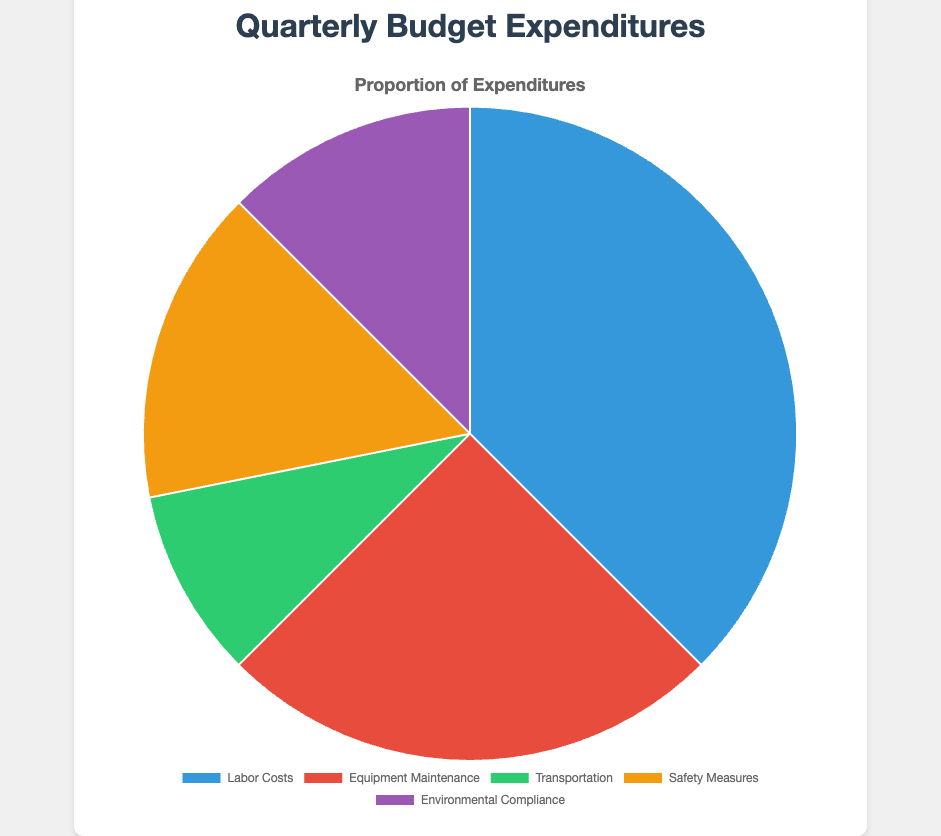What category has the highest expenditure? By looking at the pie chart, the slice labeled "Labor Costs" is the largest, indicating it has the highest expenditure.
Answer: Labor Costs How much more is spent on Labor Costs compared to Transportation? To find the difference, subtract the Transportation amount from the Labor Costs amount: $1,200,000 - $300,000 = $900,000.
Answer: $900,000 What is the percentage share of Equipment Maintenance out of the total budget? First, sum all the expenditures to get the total budget. Total = $1,200,000 + $800,000 + $300,000 + $500,000 + $400,000 = $3,200,000. Then, calculate the percentage: ($800,000 / $3,200,000) * 100 = 25%.
Answer: 25% Which category has the smallest expenditure? The smallest slice in the pie chart is labeled "Transportation," indicating it has the smallest expenditure.
Answer: Transportation What is the combined expenditure for Safety Measures and Environmental Compliance? Add the amounts for Safety Measures and Environmental Compliance: $500,000 + $400,000 = $900,000.
Answer: $900,000 Which category has a higher expenditure: Safety Measures or Environmental Compliance? By comparing the two slices, the Safety Measures slice is larger than the Environmental Compliance slice.
Answer: Safety Measures What is the ratio of Labor Costs to Equipment Maintenance? Divide the Labor Costs amount by the Equipment Maintenance amount: $1,200,000 / $800,000 = 1.5.
Answer: 1.5 If 10% of the total budget is reallocated to Safety Measures, what will be the new expenditure for Safety Measures? First, find 10% of the total budget: 10% of $3,200,000 = $320,000. Then, add this to the current Safety Measures amount: $500,000 + $320,000 = $820,000.
Answer: $820,000 What percentage of the budget is spent on categories other than Labor Costs? Sum the expenditures for Equipment Maintenance, Transportation, Safety Measures, and Environmental Compliance: $800,000 + $300,000 + $500,000 + $400,000 = $2,000,000. Then, calculate the percentage: ($2,000,000 / $3,200,000) * 100 = 62.5%.
Answer: 62.5% If the Safety Measures budget increases by 20%, what will be the new total budget? First, calculate the 20% increase for Safety Measures: 20% of $500,000 = $100,000. Add this to the current Safety Measures amount: $500,000 + $100,000 = $600,000. Then, add this increase to the original total budget: $3,200,000 + $100,000 = $3,300,000.
Answer: $3,300,000 